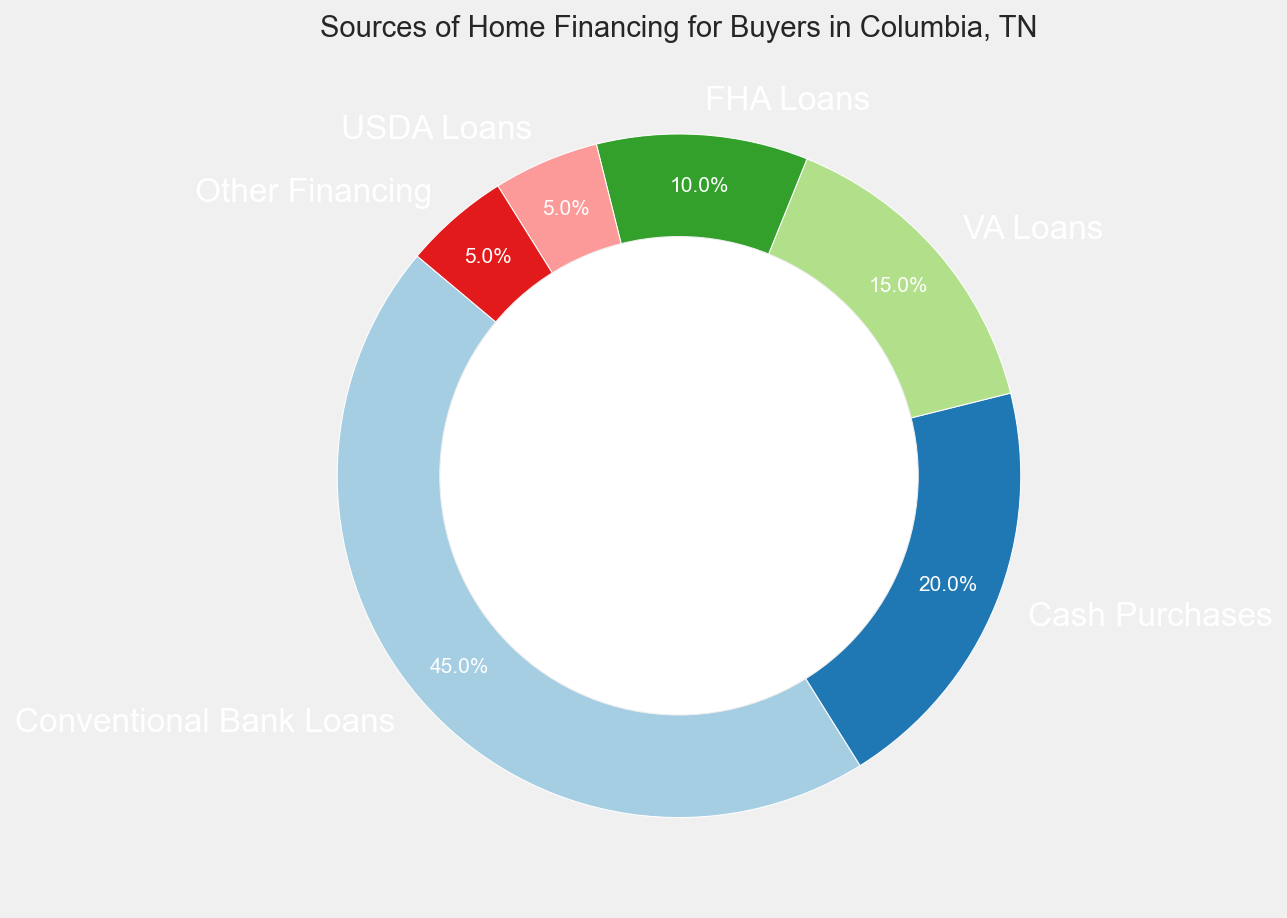What's the largest source of home financing for buyers in Columbia, TN? The chart indicates that the largest segment corresponds to Conventional Bank Loans with 45%.
Answer: Conventional Bank Loans How much higher is the percentage of Conventional Bank Loans compared to Cash Purchases? Conventional Bank Loans are 45% while Cash Purchases are 20%. The difference is 45% - 20% = 25%.
Answer: 25% What percentage of home financing is provided by VA Loans and FHA Loans combined? VA Loans account for 15% and FHA Loans account for 10%. Combined, they are 15% + 10% = 25%.
Answer: 25% Which source of home financing has the smallest share, and what is this share? The chart shows that both USDA Loans and Other Financing have the smallest share, each with 5%.
Answer: USDA Loans and Other Financing, 5% How does the percentage of Cash Purchases compare to the sum of VA Loans and FHA Loans? Cash Purchases are 20%. The sum of VA Loans (15%) and FHA Loans (10%) is 25%. Cash Purchases are 5% less than the combined VA and FHA Loans.
Answer: Cash Purchases are 5% less If the percentage of Conventional Bank Loans increased by 10%, what would the new percentage be? The current percentage is 45%. If it increases by 10%, the new percentage would be 45% + 10% = 55%.
Answer: 55% Are there more buyers using USDA Loans or Other Financing? Both USDA Loans and Other Financing have the same share of 5%.
Answer: Equal, 5% What is the combined percentage of financing sources other than Conventional Bank Loans? Financing sources other than Conventional Bank Loans are Cash Purchases (20%), VA Loans (15%), FHA Loans (10%), USDA Loans (5%), and Other Financing (5%). The combined percentage is 20% + 15% + 10% + 5% + 5% = 55%.
Answer: 55% What fraction of buyers uses either VA Loans or USDA Loans? The percentages are VA Loans (15%) and USDA Loans (5%). Combined, they account for 15% + 5% = 20%. As a fraction, this is 20/100 = 1/5 or 20%.
Answer: 1/5 or 20% 